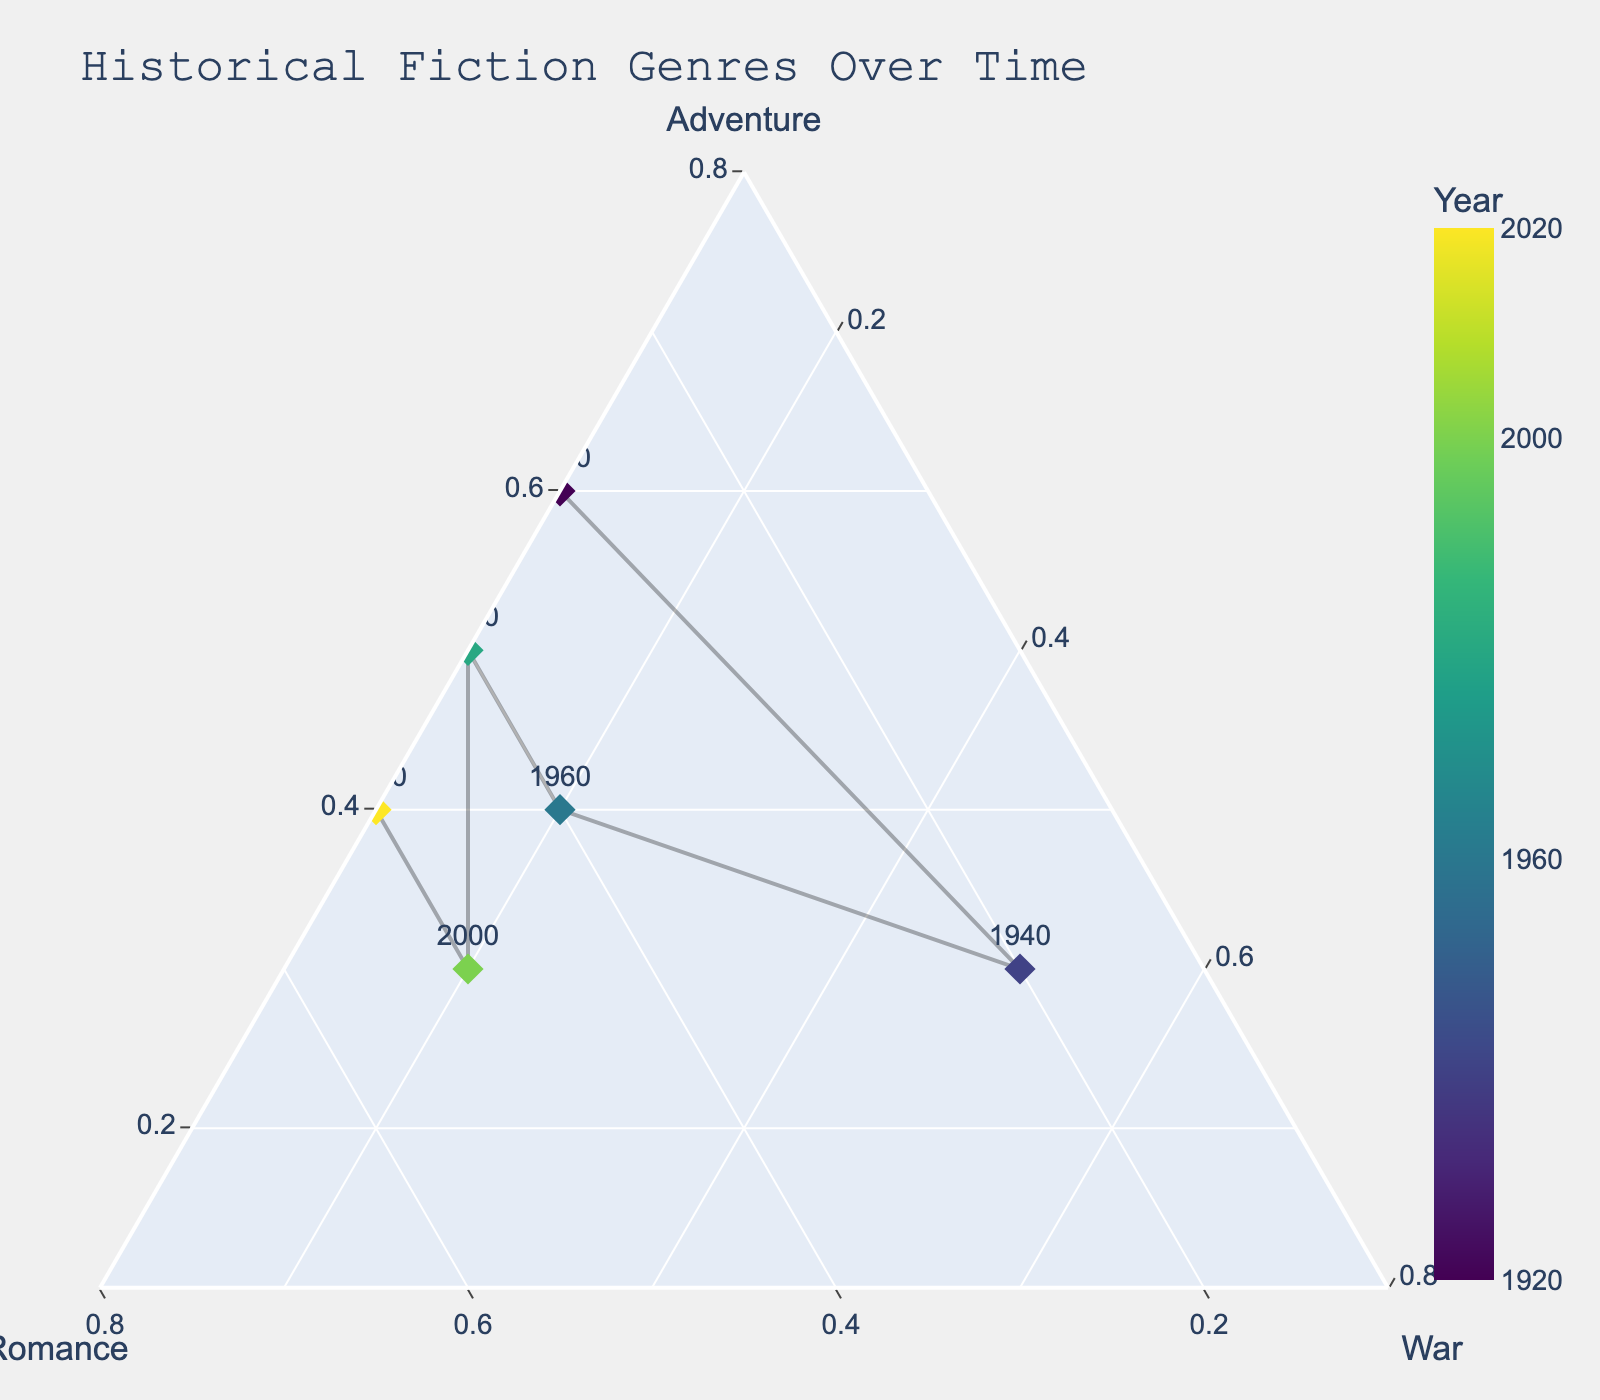What is the title of the ternary plot? The title of the ternary plot is displayed at the top in a larger font size and a bold style to easily catch the reader's attention
Answer: Historical Fiction Genres Over Time How many data points are shown in the plot? Count the number of points labeled with years on the plot. Each point represents a different year.
Answer: 6 What genre combination had the highest Adventure composition? Identify the point with the furthest position on the Adventure axis (right side of the plot).
Answer: 1920 What was the Romance composition like in the year 2000? Locate the point labeled "2000" and determine its position relative to the Romance axis.
Answer: 0.5 Which year showed the highest proportion of War fiction? Find the data point located closest to the War axis (top side of the plot).
Answer: 1940 How does the Romance composition in 2020 compare to 1960? Identify both points on the plot and compare their positions relative to the Romance axis.
Answer: Higher in 2020 What is the average Adventure composition in the years provided? Sum up the Adventure compositions for all years and divide by the number of years: (0.6 + 0.3 + 0.4 + 0.5 + 0.3 + 0.4)/6
Answer: 0.42 Which decade had an equal proportion of Adventure and Romance? Find the decade where the Adventure and Romance coordinates are equal on the ternary plot.
Answer: 1960 Did the proportion of War genre in bestselling novels increase or decrease from 1920 to 1940? Compare the War composition between 1920 and 1940 points.
Answer: Increase Which point is closest to the triangle’s center? Identify the point with balanced compositions in Adventure, Romance, and War, which is nearest to the triangle's centroid.
Answer: 1960 